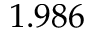Convert formula to latex. <formula><loc_0><loc_0><loc_500><loc_500>1 . 9 8 6</formula> 